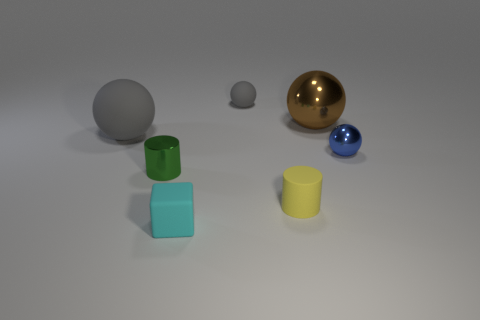Do the small matte ball and the large rubber sphere have the same color?
Offer a terse response. Yes. What size is the other rubber sphere that is the same color as the large rubber sphere?
Provide a short and direct response. Small. The big sphere that is to the right of the cyan rubber object that is in front of the small thing that is on the right side of the tiny yellow rubber object is made of what material?
Ensure brevity in your answer.  Metal. Is the color of the large sphere that is on the left side of the tiny cyan matte cube the same as the matte ball that is right of the rubber block?
Ensure brevity in your answer.  Yes. Are there fewer big blue rubber cylinders than gray matte spheres?
Offer a terse response. Yes. What material is the gray object that is the same size as the green thing?
Keep it short and to the point. Rubber. Does the thing that is right of the brown metallic sphere have the same size as the gray thing that is to the left of the cyan block?
Give a very brief answer. No. Are there any small cyan objects that have the same material as the large brown thing?
Keep it short and to the point. No. How many objects are metallic objects on the left side of the small cyan matte object or gray balls?
Your response must be concise. 3. Do the big ball to the right of the tiny matte block and the tiny gray sphere have the same material?
Provide a short and direct response. No. 